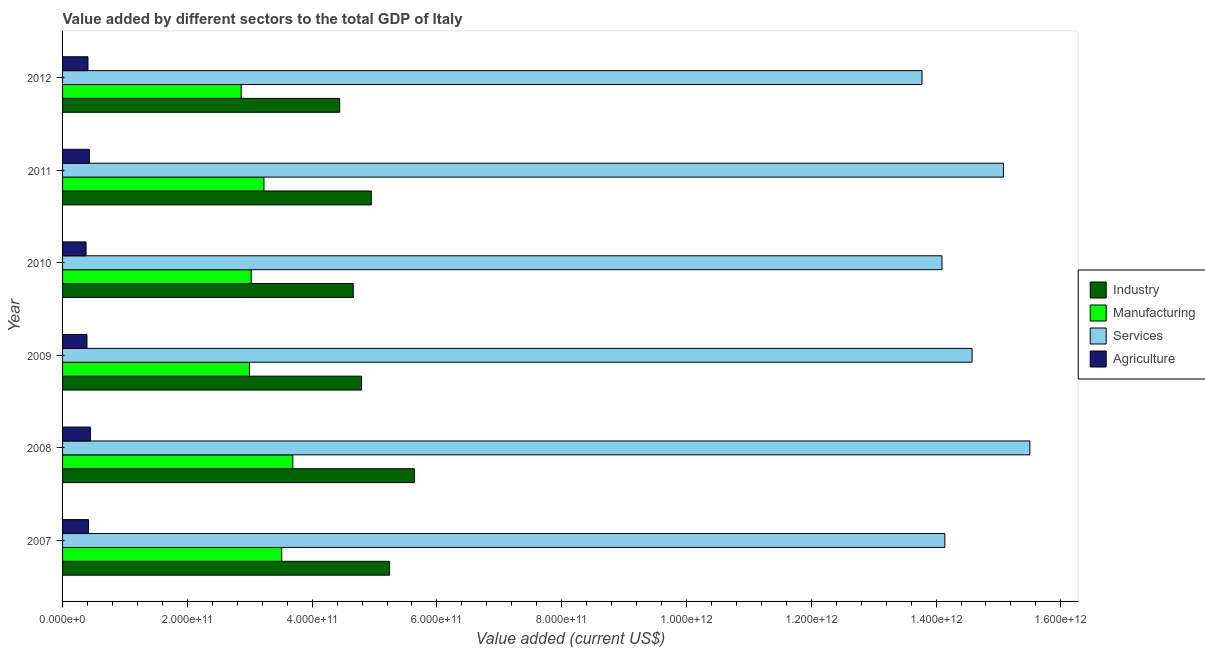How many groups of bars are there?
Provide a short and direct response. 6. What is the label of the 1st group of bars from the top?
Ensure brevity in your answer.  2012. In how many cases, is the number of bars for a given year not equal to the number of legend labels?
Offer a terse response. 0. What is the value added by agricultural sector in 2009?
Offer a terse response. 3.91e+1. Across all years, what is the maximum value added by industrial sector?
Your answer should be compact. 5.64e+11. Across all years, what is the minimum value added by services sector?
Make the answer very short. 1.38e+12. In which year was the value added by manufacturing sector minimum?
Your response must be concise. 2012. What is the total value added by industrial sector in the graph?
Make the answer very short. 2.97e+12. What is the difference between the value added by services sector in 2007 and that in 2008?
Your answer should be very brief. -1.36e+11. What is the difference between the value added by agricultural sector in 2007 and the value added by industrial sector in 2011?
Your answer should be compact. -4.53e+11. What is the average value added by services sector per year?
Your response must be concise. 1.45e+12. In the year 2008, what is the difference between the value added by industrial sector and value added by services sector?
Make the answer very short. -9.86e+11. What is the ratio of the value added by services sector in 2008 to that in 2011?
Your response must be concise. 1.03. What is the difference between the highest and the second highest value added by industrial sector?
Your answer should be compact. 3.97e+1. What is the difference between the highest and the lowest value added by agricultural sector?
Ensure brevity in your answer.  7.00e+09. Is the sum of the value added by industrial sector in 2007 and 2011 greater than the maximum value added by agricultural sector across all years?
Give a very brief answer. Yes. What does the 1st bar from the top in 2009 represents?
Provide a short and direct response. Agriculture. What does the 1st bar from the bottom in 2010 represents?
Provide a succinct answer. Industry. How many bars are there?
Offer a very short reply. 24. Are all the bars in the graph horizontal?
Your response must be concise. Yes. How many years are there in the graph?
Your answer should be compact. 6. What is the difference between two consecutive major ticks on the X-axis?
Offer a very short reply. 2.00e+11. Are the values on the major ticks of X-axis written in scientific E-notation?
Your answer should be compact. Yes. Does the graph contain any zero values?
Your response must be concise. No. How many legend labels are there?
Make the answer very short. 4. What is the title of the graph?
Offer a terse response. Value added by different sectors to the total GDP of Italy. Does "Regional development banks" appear as one of the legend labels in the graph?
Keep it short and to the point. No. What is the label or title of the X-axis?
Your answer should be very brief. Value added (current US$). What is the Value added (current US$) in Industry in 2007?
Your answer should be very brief. 5.24e+11. What is the Value added (current US$) in Manufacturing in 2007?
Your answer should be compact. 3.51e+11. What is the Value added (current US$) in Services in 2007?
Your answer should be very brief. 1.41e+12. What is the Value added (current US$) in Agriculture in 2007?
Provide a short and direct response. 4.17e+1. What is the Value added (current US$) in Industry in 2008?
Give a very brief answer. 5.64e+11. What is the Value added (current US$) in Manufacturing in 2008?
Give a very brief answer. 3.69e+11. What is the Value added (current US$) in Services in 2008?
Provide a succinct answer. 1.55e+12. What is the Value added (current US$) of Agriculture in 2008?
Your response must be concise. 4.46e+1. What is the Value added (current US$) in Industry in 2009?
Make the answer very short. 4.79e+11. What is the Value added (current US$) of Manufacturing in 2009?
Provide a succinct answer. 3.00e+11. What is the Value added (current US$) in Services in 2009?
Offer a terse response. 1.46e+12. What is the Value added (current US$) in Agriculture in 2009?
Your answer should be very brief. 3.91e+1. What is the Value added (current US$) in Industry in 2010?
Provide a short and direct response. 4.66e+11. What is the Value added (current US$) in Manufacturing in 2010?
Provide a succinct answer. 3.02e+11. What is the Value added (current US$) in Services in 2010?
Offer a very short reply. 1.41e+12. What is the Value added (current US$) in Agriculture in 2010?
Provide a succinct answer. 3.76e+1. What is the Value added (current US$) in Industry in 2011?
Your answer should be compact. 4.95e+11. What is the Value added (current US$) of Manufacturing in 2011?
Keep it short and to the point. 3.23e+11. What is the Value added (current US$) in Services in 2011?
Provide a short and direct response. 1.51e+12. What is the Value added (current US$) in Agriculture in 2011?
Give a very brief answer. 4.29e+1. What is the Value added (current US$) of Industry in 2012?
Provide a succinct answer. 4.44e+11. What is the Value added (current US$) in Manufacturing in 2012?
Give a very brief answer. 2.86e+11. What is the Value added (current US$) in Services in 2012?
Ensure brevity in your answer.  1.38e+12. What is the Value added (current US$) in Agriculture in 2012?
Offer a very short reply. 4.07e+1. Across all years, what is the maximum Value added (current US$) in Industry?
Ensure brevity in your answer.  5.64e+11. Across all years, what is the maximum Value added (current US$) of Manufacturing?
Give a very brief answer. 3.69e+11. Across all years, what is the maximum Value added (current US$) in Services?
Provide a short and direct response. 1.55e+12. Across all years, what is the maximum Value added (current US$) of Agriculture?
Keep it short and to the point. 4.46e+1. Across all years, what is the minimum Value added (current US$) of Industry?
Ensure brevity in your answer.  4.44e+11. Across all years, what is the minimum Value added (current US$) of Manufacturing?
Your answer should be very brief. 2.86e+11. Across all years, what is the minimum Value added (current US$) of Services?
Your answer should be compact. 1.38e+12. Across all years, what is the minimum Value added (current US$) of Agriculture?
Give a very brief answer. 3.76e+1. What is the total Value added (current US$) of Industry in the graph?
Offer a terse response. 2.97e+12. What is the total Value added (current US$) of Manufacturing in the graph?
Your answer should be compact. 1.93e+12. What is the total Value added (current US$) in Services in the graph?
Keep it short and to the point. 8.72e+12. What is the total Value added (current US$) of Agriculture in the graph?
Your answer should be compact. 2.47e+11. What is the difference between the Value added (current US$) of Industry in 2007 and that in 2008?
Provide a succinct answer. -3.97e+1. What is the difference between the Value added (current US$) of Manufacturing in 2007 and that in 2008?
Offer a terse response. -1.77e+1. What is the difference between the Value added (current US$) of Services in 2007 and that in 2008?
Provide a succinct answer. -1.36e+11. What is the difference between the Value added (current US$) in Agriculture in 2007 and that in 2008?
Offer a terse response. -2.98e+09. What is the difference between the Value added (current US$) in Industry in 2007 and that in 2009?
Your answer should be compact. 4.49e+1. What is the difference between the Value added (current US$) of Manufacturing in 2007 and that in 2009?
Offer a very short reply. 5.17e+1. What is the difference between the Value added (current US$) of Services in 2007 and that in 2009?
Give a very brief answer. -4.36e+1. What is the difference between the Value added (current US$) in Agriculture in 2007 and that in 2009?
Your answer should be very brief. 2.55e+09. What is the difference between the Value added (current US$) of Industry in 2007 and that in 2010?
Provide a short and direct response. 5.82e+1. What is the difference between the Value added (current US$) of Manufacturing in 2007 and that in 2010?
Offer a very short reply. 4.89e+1. What is the difference between the Value added (current US$) in Services in 2007 and that in 2010?
Your answer should be compact. 4.55e+09. What is the difference between the Value added (current US$) of Agriculture in 2007 and that in 2010?
Ensure brevity in your answer.  4.02e+09. What is the difference between the Value added (current US$) in Industry in 2007 and that in 2011?
Provide a succinct answer. 2.93e+1. What is the difference between the Value added (current US$) of Manufacturing in 2007 and that in 2011?
Give a very brief answer. 2.85e+1. What is the difference between the Value added (current US$) of Services in 2007 and that in 2011?
Provide a succinct answer. -9.39e+1. What is the difference between the Value added (current US$) of Agriculture in 2007 and that in 2011?
Provide a succinct answer. -1.27e+09. What is the difference between the Value added (current US$) in Industry in 2007 and that in 2012?
Offer a terse response. 8.00e+1. What is the difference between the Value added (current US$) of Manufacturing in 2007 and that in 2012?
Your answer should be very brief. 6.50e+1. What is the difference between the Value added (current US$) of Services in 2007 and that in 2012?
Your answer should be compact. 3.67e+1. What is the difference between the Value added (current US$) in Agriculture in 2007 and that in 2012?
Keep it short and to the point. 9.26e+08. What is the difference between the Value added (current US$) of Industry in 2008 and that in 2009?
Offer a terse response. 8.46e+1. What is the difference between the Value added (current US$) of Manufacturing in 2008 and that in 2009?
Make the answer very short. 6.95e+1. What is the difference between the Value added (current US$) of Services in 2008 and that in 2009?
Give a very brief answer. 9.26e+1. What is the difference between the Value added (current US$) in Agriculture in 2008 and that in 2009?
Offer a very short reply. 5.53e+09. What is the difference between the Value added (current US$) in Industry in 2008 and that in 2010?
Your answer should be very brief. 9.79e+1. What is the difference between the Value added (current US$) in Manufacturing in 2008 and that in 2010?
Your response must be concise. 6.66e+1. What is the difference between the Value added (current US$) of Services in 2008 and that in 2010?
Provide a succinct answer. 1.41e+11. What is the difference between the Value added (current US$) of Agriculture in 2008 and that in 2010?
Offer a terse response. 7.00e+09. What is the difference between the Value added (current US$) in Industry in 2008 and that in 2011?
Provide a succinct answer. 6.91e+1. What is the difference between the Value added (current US$) in Manufacturing in 2008 and that in 2011?
Your answer should be compact. 4.62e+1. What is the difference between the Value added (current US$) of Services in 2008 and that in 2011?
Provide a succinct answer. 4.23e+1. What is the difference between the Value added (current US$) in Agriculture in 2008 and that in 2011?
Ensure brevity in your answer.  1.71e+09. What is the difference between the Value added (current US$) of Industry in 2008 and that in 2012?
Your response must be concise. 1.20e+11. What is the difference between the Value added (current US$) in Manufacturing in 2008 and that in 2012?
Give a very brief answer. 8.27e+1. What is the difference between the Value added (current US$) in Services in 2008 and that in 2012?
Your answer should be very brief. 1.73e+11. What is the difference between the Value added (current US$) in Agriculture in 2008 and that in 2012?
Make the answer very short. 3.91e+09. What is the difference between the Value added (current US$) in Industry in 2009 and that in 2010?
Provide a short and direct response. 1.33e+1. What is the difference between the Value added (current US$) in Manufacturing in 2009 and that in 2010?
Give a very brief answer. -2.81e+09. What is the difference between the Value added (current US$) of Services in 2009 and that in 2010?
Your answer should be very brief. 4.82e+1. What is the difference between the Value added (current US$) in Agriculture in 2009 and that in 2010?
Make the answer very short. 1.47e+09. What is the difference between the Value added (current US$) of Industry in 2009 and that in 2011?
Give a very brief answer. -1.55e+1. What is the difference between the Value added (current US$) of Manufacturing in 2009 and that in 2011?
Ensure brevity in your answer.  -2.32e+1. What is the difference between the Value added (current US$) of Services in 2009 and that in 2011?
Offer a terse response. -5.03e+1. What is the difference between the Value added (current US$) of Agriculture in 2009 and that in 2011?
Give a very brief answer. -3.82e+09. What is the difference between the Value added (current US$) in Industry in 2009 and that in 2012?
Provide a succinct answer. 3.51e+1. What is the difference between the Value added (current US$) in Manufacturing in 2009 and that in 2012?
Provide a short and direct response. 1.33e+1. What is the difference between the Value added (current US$) of Services in 2009 and that in 2012?
Provide a succinct answer. 8.03e+1. What is the difference between the Value added (current US$) in Agriculture in 2009 and that in 2012?
Keep it short and to the point. -1.62e+09. What is the difference between the Value added (current US$) of Industry in 2010 and that in 2011?
Offer a very short reply. -2.89e+1. What is the difference between the Value added (current US$) in Manufacturing in 2010 and that in 2011?
Offer a very short reply. -2.04e+1. What is the difference between the Value added (current US$) of Services in 2010 and that in 2011?
Offer a terse response. -9.85e+1. What is the difference between the Value added (current US$) of Agriculture in 2010 and that in 2011?
Keep it short and to the point. -5.29e+09. What is the difference between the Value added (current US$) of Industry in 2010 and that in 2012?
Ensure brevity in your answer.  2.18e+1. What is the difference between the Value added (current US$) in Manufacturing in 2010 and that in 2012?
Offer a terse response. 1.61e+1. What is the difference between the Value added (current US$) in Services in 2010 and that in 2012?
Provide a succinct answer. 3.21e+1. What is the difference between the Value added (current US$) in Agriculture in 2010 and that in 2012?
Give a very brief answer. -3.09e+09. What is the difference between the Value added (current US$) of Industry in 2011 and that in 2012?
Offer a very short reply. 5.07e+1. What is the difference between the Value added (current US$) of Manufacturing in 2011 and that in 2012?
Offer a terse response. 3.65e+1. What is the difference between the Value added (current US$) in Services in 2011 and that in 2012?
Keep it short and to the point. 1.31e+11. What is the difference between the Value added (current US$) of Agriculture in 2011 and that in 2012?
Make the answer very short. 2.20e+09. What is the difference between the Value added (current US$) of Industry in 2007 and the Value added (current US$) of Manufacturing in 2008?
Give a very brief answer. 1.55e+11. What is the difference between the Value added (current US$) in Industry in 2007 and the Value added (current US$) in Services in 2008?
Offer a very short reply. -1.03e+12. What is the difference between the Value added (current US$) of Industry in 2007 and the Value added (current US$) of Agriculture in 2008?
Your response must be concise. 4.80e+11. What is the difference between the Value added (current US$) in Manufacturing in 2007 and the Value added (current US$) in Services in 2008?
Provide a succinct answer. -1.20e+12. What is the difference between the Value added (current US$) of Manufacturing in 2007 and the Value added (current US$) of Agriculture in 2008?
Ensure brevity in your answer.  3.07e+11. What is the difference between the Value added (current US$) of Services in 2007 and the Value added (current US$) of Agriculture in 2008?
Keep it short and to the point. 1.37e+12. What is the difference between the Value added (current US$) in Industry in 2007 and the Value added (current US$) in Manufacturing in 2009?
Offer a very short reply. 2.25e+11. What is the difference between the Value added (current US$) in Industry in 2007 and the Value added (current US$) in Services in 2009?
Your answer should be very brief. -9.34e+11. What is the difference between the Value added (current US$) of Industry in 2007 and the Value added (current US$) of Agriculture in 2009?
Provide a succinct answer. 4.85e+11. What is the difference between the Value added (current US$) of Manufacturing in 2007 and the Value added (current US$) of Services in 2009?
Give a very brief answer. -1.11e+12. What is the difference between the Value added (current US$) in Manufacturing in 2007 and the Value added (current US$) in Agriculture in 2009?
Provide a short and direct response. 3.12e+11. What is the difference between the Value added (current US$) in Services in 2007 and the Value added (current US$) in Agriculture in 2009?
Your response must be concise. 1.38e+12. What is the difference between the Value added (current US$) in Industry in 2007 and the Value added (current US$) in Manufacturing in 2010?
Offer a terse response. 2.22e+11. What is the difference between the Value added (current US$) in Industry in 2007 and the Value added (current US$) in Services in 2010?
Make the answer very short. -8.85e+11. What is the difference between the Value added (current US$) in Industry in 2007 and the Value added (current US$) in Agriculture in 2010?
Keep it short and to the point. 4.87e+11. What is the difference between the Value added (current US$) of Manufacturing in 2007 and the Value added (current US$) of Services in 2010?
Your answer should be very brief. -1.06e+12. What is the difference between the Value added (current US$) in Manufacturing in 2007 and the Value added (current US$) in Agriculture in 2010?
Your response must be concise. 3.14e+11. What is the difference between the Value added (current US$) of Services in 2007 and the Value added (current US$) of Agriculture in 2010?
Give a very brief answer. 1.38e+12. What is the difference between the Value added (current US$) in Industry in 2007 and the Value added (current US$) in Manufacturing in 2011?
Your response must be concise. 2.01e+11. What is the difference between the Value added (current US$) of Industry in 2007 and the Value added (current US$) of Services in 2011?
Provide a short and direct response. -9.84e+11. What is the difference between the Value added (current US$) in Industry in 2007 and the Value added (current US$) in Agriculture in 2011?
Offer a very short reply. 4.81e+11. What is the difference between the Value added (current US$) in Manufacturing in 2007 and the Value added (current US$) in Services in 2011?
Provide a short and direct response. -1.16e+12. What is the difference between the Value added (current US$) of Manufacturing in 2007 and the Value added (current US$) of Agriculture in 2011?
Your answer should be compact. 3.08e+11. What is the difference between the Value added (current US$) of Services in 2007 and the Value added (current US$) of Agriculture in 2011?
Offer a very short reply. 1.37e+12. What is the difference between the Value added (current US$) in Industry in 2007 and the Value added (current US$) in Manufacturing in 2012?
Offer a terse response. 2.38e+11. What is the difference between the Value added (current US$) of Industry in 2007 and the Value added (current US$) of Services in 2012?
Ensure brevity in your answer.  -8.53e+11. What is the difference between the Value added (current US$) in Industry in 2007 and the Value added (current US$) in Agriculture in 2012?
Your response must be concise. 4.83e+11. What is the difference between the Value added (current US$) in Manufacturing in 2007 and the Value added (current US$) in Services in 2012?
Keep it short and to the point. -1.03e+12. What is the difference between the Value added (current US$) in Manufacturing in 2007 and the Value added (current US$) in Agriculture in 2012?
Ensure brevity in your answer.  3.11e+11. What is the difference between the Value added (current US$) of Services in 2007 and the Value added (current US$) of Agriculture in 2012?
Your answer should be very brief. 1.37e+12. What is the difference between the Value added (current US$) in Industry in 2008 and the Value added (current US$) in Manufacturing in 2009?
Your answer should be very brief. 2.64e+11. What is the difference between the Value added (current US$) of Industry in 2008 and the Value added (current US$) of Services in 2009?
Make the answer very short. -8.94e+11. What is the difference between the Value added (current US$) of Industry in 2008 and the Value added (current US$) of Agriculture in 2009?
Offer a terse response. 5.25e+11. What is the difference between the Value added (current US$) in Manufacturing in 2008 and the Value added (current US$) in Services in 2009?
Make the answer very short. -1.09e+12. What is the difference between the Value added (current US$) in Manufacturing in 2008 and the Value added (current US$) in Agriculture in 2009?
Offer a very short reply. 3.30e+11. What is the difference between the Value added (current US$) in Services in 2008 and the Value added (current US$) in Agriculture in 2009?
Give a very brief answer. 1.51e+12. What is the difference between the Value added (current US$) in Industry in 2008 and the Value added (current US$) in Manufacturing in 2010?
Provide a succinct answer. 2.61e+11. What is the difference between the Value added (current US$) in Industry in 2008 and the Value added (current US$) in Services in 2010?
Keep it short and to the point. -8.46e+11. What is the difference between the Value added (current US$) in Industry in 2008 and the Value added (current US$) in Agriculture in 2010?
Offer a very short reply. 5.26e+11. What is the difference between the Value added (current US$) in Manufacturing in 2008 and the Value added (current US$) in Services in 2010?
Provide a short and direct response. -1.04e+12. What is the difference between the Value added (current US$) in Manufacturing in 2008 and the Value added (current US$) in Agriculture in 2010?
Your answer should be very brief. 3.31e+11. What is the difference between the Value added (current US$) of Services in 2008 and the Value added (current US$) of Agriculture in 2010?
Offer a terse response. 1.51e+12. What is the difference between the Value added (current US$) of Industry in 2008 and the Value added (current US$) of Manufacturing in 2011?
Offer a very short reply. 2.41e+11. What is the difference between the Value added (current US$) in Industry in 2008 and the Value added (current US$) in Services in 2011?
Offer a very short reply. -9.44e+11. What is the difference between the Value added (current US$) in Industry in 2008 and the Value added (current US$) in Agriculture in 2011?
Keep it short and to the point. 5.21e+11. What is the difference between the Value added (current US$) in Manufacturing in 2008 and the Value added (current US$) in Services in 2011?
Keep it short and to the point. -1.14e+12. What is the difference between the Value added (current US$) in Manufacturing in 2008 and the Value added (current US$) in Agriculture in 2011?
Provide a succinct answer. 3.26e+11. What is the difference between the Value added (current US$) in Services in 2008 and the Value added (current US$) in Agriculture in 2011?
Provide a short and direct response. 1.51e+12. What is the difference between the Value added (current US$) of Industry in 2008 and the Value added (current US$) of Manufacturing in 2012?
Give a very brief answer. 2.78e+11. What is the difference between the Value added (current US$) of Industry in 2008 and the Value added (current US$) of Services in 2012?
Ensure brevity in your answer.  -8.14e+11. What is the difference between the Value added (current US$) in Industry in 2008 and the Value added (current US$) in Agriculture in 2012?
Your response must be concise. 5.23e+11. What is the difference between the Value added (current US$) of Manufacturing in 2008 and the Value added (current US$) of Services in 2012?
Offer a terse response. -1.01e+12. What is the difference between the Value added (current US$) in Manufacturing in 2008 and the Value added (current US$) in Agriculture in 2012?
Your response must be concise. 3.28e+11. What is the difference between the Value added (current US$) of Services in 2008 and the Value added (current US$) of Agriculture in 2012?
Your response must be concise. 1.51e+12. What is the difference between the Value added (current US$) in Industry in 2009 and the Value added (current US$) in Manufacturing in 2010?
Offer a terse response. 1.77e+11. What is the difference between the Value added (current US$) in Industry in 2009 and the Value added (current US$) in Services in 2010?
Your answer should be very brief. -9.30e+11. What is the difference between the Value added (current US$) of Industry in 2009 and the Value added (current US$) of Agriculture in 2010?
Your answer should be compact. 4.42e+11. What is the difference between the Value added (current US$) of Manufacturing in 2009 and the Value added (current US$) of Services in 2010?
Your answer should be compact. -1.11e+12. What is the difference between the Value added (current US$) of Manufacturing in 2009 and the Value added (current US$) of Agriculture in 2010?
Provide a succinct answer. 2.62e+11. What is the difference between the Value added (current US$) of Services in 2009 and the Value added (current US$) of Agriculture in 2010?
Ensure brevity in your answer.  1.42e+12. What is the difference between the Value added (current US$) of Industry in 2009 and the Value added (current US$) of Manufacturing in 2011?
Provide a succinct answer. 1.57e+11. What is the difference between the Value added (current US$) in Industry in 2009 and the Value added (current US$) in Services in 2011?
Your answer should be compact. -1.03e+12. What is the difference between the Value added (current US$) in Industry in 2009 and the Value added (current US$) in Agriculture in 2011?
Offer a terse response. 4.36e+11. What is the difference between the Value added (current US$) in Manufacturing in 2009 and the Value added (current US$) in Services in 2011?
Offer a very short reply. -1.21e+12. What is the difference between the Value added (current US$) of Manufacturing in 2009 and the Value added (current US$) of Agriculture in 2011?
Your response must be concise. 2.57e+11. What is the difference between the Value added (current US$) of Services in 2009 and the Value added (current US$) of Agriculture in 2011?
Offer a terse response. 1.41e+12. What is the difference between the Value added (current US$) in Industry in 2009 and the Value added (current US$) in Manufacturing in 2012?
Your answer should be very brief. 1.93e+11. What is the difference between the Value added (current US$) in Industry in 2009 and the Value added (current US$) in Services in 2012?
Give a very brief answer. -8.98e+11. What is the difference between the Value added (current US$) in Industry in 2009 and the Value added (current US$) in Agriculture in 2012?
Offer a terse response. 4.39e+11. What is the difference between the Value added (current US$) in Manufacturing in 2009 and the Value added (current US$) in Services in 2012?
Offer a terse response. -1.08e+12. What is the difference between the Value added (current US$) in Manufacturing in 2009 and the Value added (current US$) in Agriculture in 2012?
Keep it short and to the point. 2.59e+11. What is the difference between the Value added (current US$) of Services in 2009 and the Value added (current US$) of Agriculture in 2012?
Provide a succinct answer. 1.42e+12. What is the difference between the Value added (current US$) in Industry in 2010 and the Value added (current US$) in Manufacturing in 2011?
Offer a terse response. 1.43e+11. What is the difference between the Value added (current US$) in Industry in 2010 and the Value added (current US$) in Services in 2011?
Your answer should be compact. -1.04e+12. What is the difference between the Value added (current US$) in Industry in 2010 and the Value added (current US$) in Agriculture in 2011?
Offer a very short reply. 4.23e+11. What is the difference between the Value added (current US$) in Manufacturing in 2010 and the Value added (current US$) in Services in 2011?
Your response must be concise. -1.21e+12. What is the difference between the Value added (current US$) of Manufacturing in 2010 and the Value added (current US$) of Agriculture in 2011?
Your response must be concise. 2.59e+11. What is the difference between the Value added (current US$) in Services in 2010 and the Value added (current US$) in Agriculture in 2011?
Your response must be concise. 1.37e+12. What is the difference between the Value added (current US$) of Industry in 2010 and the Value added (current US$) of Manufacturing in 2012?
Give a very brief answer. 1.80e+11. What is the difference between the Value added (current US$) in Industry in 2010 and the Value added (current US$) in Services in 2012?
Offer a terse response. -9.12e+11. What is the difference between the Value added (current US$) of Industry in 2010 and the Value added (current US$) of Agriculture in 2012?
Ensure brevity in your answer.  4.25e+11. What is the difference between the Value added (current US$) in Manufacturing in 2010 and the Value added (current US$) in Services in 2012?
Your answer should be very brief. -1.08e+12. What is the difference between the Value added (current US$) in Manufacturing in 2010 and the Value added (current US$) in Agriculture in 2012?
Your answer should be very brief. 2.62e+11. What is the difference between the Value added (current US$) of Services in 2010 and the Value added (current US$) of Agriculture in 2012?
Keep it short and to the point. 1.37e+12. What is the difference between the Value added (current US$) of Industry in 2011 and the Value added (current US$) of Manufacturing in 2012?
Your answer should be very brief. 2.09e+11. What is the difference between the Value added (current US$) in Industry in 2011 and the Value added (current US$) in Services in 2012?
Make the answer very short. -8.83e+11. What is the difference between the Value added (current US$) in Industry in 2011 and the Value added (current US$) in Agriculture in 2012?
Give a very brief answer. 4.54e+11. What is the difference between the Value added (current US$) in Manufacturing in 2011 and the Value added (current US$) in Services in 2012?
Make the answer very short. -1.05e+12. What is the difference between the Value added (current US$) of Manufacturing in 2011 and the Value added (current US$) of Agriculture in 2012?
Provide a succinct answer. 2.82e+11. What is the difference between the Value added (current US$) in Services in 2011 and the Value added (current US$) in Agriculture in 2012?
Offer a very short reply. 1.47e+12. What is the average Value added (current US$) in Industry per year?
Keep it short and to the point. 4.95e+11. What is the average Value added (current US$) in Manufacturing per year?
Make the answer very short. 3.22e+11. What is the average Value added (current US$) in Services per year?
Make the answer very short. 1.45e+12. What is the average Value added (current US$) of Agriculture per year?
Your answer should be very brief. 4.11e+1. In the year 2007, what is the difference between the Value added (current US$) of Industry and Value added (current US$) of Manufacturing?
Your response must be concise. 1.73e+11. In the year 2007, what is the difference between the Value added (current US$) of Industry and Value added (current US$) of Services?
Your answer should be compact. -8.90e+11. In the year 2007, what is the difference between the Value added (current US$) of Industry and Value added (current US$) of Agriculture?
Your response must be concise. 4.82e+11. In the year 2007, what is the difference between the Value added (current US$) of Manufacturing and Value added (current US$) of Services?
Your answer should be compact. -1.06e+12. In the year 2007, what is the difference between the Value added (current US$) in Manufacturing and Value added (current US$) in Agriculture?
Make the answer very short. 3.10e+11. In the year 2007, what is the difference between the Value added (current US$) in Services and Value added (current US$) in Agriculture?
Provide a short and direct response. 1.37e+12. In the year 2008, what is the difference between the Value added (current US$) in Industry and Value added (current US$) in Manufacturing?
Make the answer very short. 1.95e+11. In the year 2008, what is the difference between the Value added (current US$) of Industry and Value added (current US$) of Services?
Offer a terse response. -9.86e+11. In the year 2008, what is the difference between the Value added (current US$) of Industry and Value added (current US$) of Agriculture?
Offer a very short reply. 5.19e+11. In the year 2008, what is the difference between the Value added (current US$) in Manufacturing and Value added (current US$) in Services?
Offer a terse response. -1.18e+12. In the year 2008, what is the difference between the Value added (current US$) of Manufacturing and Value added (current US$) of Agriculture?
Give a very brief answer. 3.24e+11. In the year 2008, what is the difference between the Value added (current US$) of Services and Value added (current US$) of Agriculture?
Ensure brevity in your answer.  1.51e+12. In the year 2009, what is the difference between the Value added (current US$) of Industry and Value added (current US$) of Manufacturing?
Give a very brief answer. 1.80e+11. In the year 2009, what is the difference between the Value added (current US$) of Industry and Value added (current US$) of Services?
Offer a very short reply. -9.78e+11. In the year 2009, what is the difference between the Value added (current US$) in Industry and Value added (current US$) in Agriculture?
Provide a short and direct response. 4.40e+11. In the year 2009, what is the difference between the Value added (current US$) in Manufacturing and Value added (current US$) in Services?
Give a very brief answer. -1.16e+12. In the year 2009, what is the difference between the Value added (current US$) of Manufacturing and Value added (current US$) of Agriculture?
Make the answer very short. 2.60e+11. In the year 2009, what is the difference between the Value added (current US$) in Services and Value added (current US$) in Agriculture?
Make the answer very short. 1.42e+12. In the year 2010, what is the difference between the Value added (current US$) in Industry and Value added (current US$) in Manufacturing?
Give a very brief answer. 1.64e+11. In the year 2010, what is the difference between the Value added (current US$) of Industry and Value added (current US$) of Services?
Provide a short and direct response. -9.44e+11. In the year 2010, what is the difference between the Value added (current US$) of Industry and Value added (current US$) of Agriculture?
Keep it short and to the point. 4.28e+11. In the year 2010, what is the difference between the Value added (current US$) in Manufacturing and Value added (current US$) in Services?
Your response must be concise. -1.11e+12. In the year 2010, what is the difference between the Value added (current US$) in Manufacturing and Value added (current US$) in Agriculture?
Your answer should be very brief. 2.65e+11. In the year 2010, what is the difference between the Value added (current US$) in Services and Value added (current US$) in Agriculture?
Ensure brevity in your answer.  1.37e+12. In the year 2011, what is the difference between the Value added (current US$) in Industry and Value added (current US$) in Manufacturing?
Your answer should be compact. 1.72e+11. In the year 2011, what is the difference between the Value added (current US$) of Industry and Value added (current US$) of Services?
Your answer should be very brief. -1.01e+12. In the year 2011, what is the difference between the Value added (current US$) in Industry and Value added (current US$) in Agriculture?
Your response must be concise. 4.52e+11. In the year 2011, what is the difference between the Value added (current US$) in Manufacturing and Value added (current US$) in Services?
Provide a succinct answer. -1.19e+12. In the year 2011, what is the difference between the Value added (current US$) of Manufacturing and Value added (current US$) of Agriculture?
Your response must be concise. 2.80e+11. In the year 2011, what is the difference between the Value added (current US$) in Services and Value added (current US$) in Agriculture?
Keep it short and to the point. 1.47e+12. In the year 2012, what is the difference between the Value added (current US$) of Industry and Value added (current US$) of Manufacturing?
Keep it short and to the point. 1.58e+11. In the year 2012, what is the difference between the Value added (current US$) of Industry and Value added (current US$) of Services?
Your response must be concise. -9.33e+11. In the year 2012, what is the difference between the Value added (current US$) in Industry and Value added (current US$) in Agriculture?
Keep it short and to the point. 4.03e+11. In the year 2012, what is the difference between the Value added (current US$) of Manufacturing and Value added (current US$) of Services?
Your answer should be very brief. -1.09e+12. In the year 2012, what is the difference between the Value added (current US$) of Manufacturing and Value added (current US$) of Agriculture?
Keep it short and to the point. 2.46e+11. In the year 2012, what is the difference between the Value added (current US$) of Services and Value added (current US$) of Agriculture?
Provide a succinct answer. 1.34e+12. What is the ratio of the Value added (current US$) of Industry in 2007 to that in 2008?
Provide a short and direct response. 0.93. What is the ratio of the Value added (current US$) of Services in 2007 to that in 2008?
Ensure brevity in your answer.  0.91. What is the ratio of the Value added (current US$) in Agriculture in 2007 to that in 2008?
Your response must be concise. 0.93. What is the ratio of the Value added (current US$) in Industry in 2007 to that in 2009?
Make the answer very short. 1.09. What is the ratio of the Value added (current US$) of Manufacturing in 2007 to that in 2009?
Your answer should be very brief. 1.17. What is the ratio of the Value added (current US$) of Services in 2007 to that in 2009?
Your response must be concise. 0.97. What is the ratio of the Value added (current US$) of Agriculture in 2007 to that in 2009?
Your answer should be compact. 1.07. What is the ratio of the Value added (current US$) in Industry in 2007 to that in 2010?
Offer a very short reply. 1.12. What is the ratio of the Value added (current US$) of Manufacturing in 2007 to that in 2010?
Provide a short and direct response. 1.16. What is the ratio of the Value added (current US$) in Services in 2007 to that in 2010?
Provide a short and direct response. 1. What is the ratio of the Value added (current US$) in Agriculture in 2007 to that in 2010?
Your answer should be compact. 1.11. What is the ratio of the Value added (current US$) in Industry in 2007 to that in 2011?
Make the answer very short. 1.06. What is the ratio of the Value added (current US$) in Manufacturing in 2007 to that in 2011?
Provide a short and direct response. 1.09. What is the ratio of the Value added (current US$) in Services in 2007 to that in 2011?
Give a very brief answer. 0.94. What is the ratio of the Value added (current US$) in Agriculture in 2007 to that in 2011?
Make the answer very short. 0.97. What is the ratio of the Value added (current US$) of Industry in 2007 to that in 2012?
Offer a terse response. 1.18. What is the ratio of the Value added (current US$) of Manufacturing in 2007 to that in 2012?
Ensure brevity in your answer.  1.23. What is the ratio of the Value added (current US$) of Services in 2007 to that in 2012?
Keep it short and to the point. 1.03. What is the ratio of the Value added (current US$) of Agriculture in 2007 to that in 2012?
Offer a very short reply. 1.02. What is the ratio of the Value added (current US$) of Industry in 2008 to that in 2009?
Offer a terse response. 1.18. What is the ratio of the Value added (current US$) of Manufacturing in 2008 to that in 2009?
Give a very brief answer. 1.23. What is the ratio of the Value added (current US$) of Services in 2008 to that in 2009?
Make the answer very short. 1.06. What is the ratio of the Value added (current US$) of Agriculture in 2008 to that in 2009?
Give a very brief answer. 1.14. What is the ratio of the Value added (current US$) in Industry in 2008 to that in 2010?
Your answer should be compact. 1.21. What is the ratio of the Value added (current US$) in Manufacturing in 2008 to that in 2010?
Give a very brief answer. 1.22. What is the ratio of the Value added (current US$) of Services in 2008 to that in 2010?
Provide a succinct answer. 1.1. What is the ratio of the Value added (current US$) in Agriculture in 2008 to that in 2010?
Give a very brief answer. 1.19. What is the ratio of the Value added (current US$) in Industry in 2008 to that in 2011?
Provide a succinct answer. 1.14. What is the ratio of the Value added (current US$) of Manufacturing in 2008 to that in 2011?
Offer a terse response. 1.14. What is the ratio of the Value added (current US$) of Services in 2008 to that in 2011?
Make the answer very short. 1.03. What is the ratio of the Value added (current US$) in Agriculture in 2008 to that in 2011?
Ensure brevity in your answer.  1.04. What is the ratio of the Value added (current US$) in Industry in 2008 to that in 2012?
Your answer should be very brief. 1.27. What is the ratio of the Value added (current US$) in Manufacturing in 2008 to that in 2012?
Offer a terse response. 1.29. What is the ratio of the Value added (current US$) in Services in 2008 to that in 2012?
Ensure brevity in your answer.  1.13. What is the ratio of the Value added (current US$) of Agriculture in 2008 to that in 2012?
Offer a terse response. 1.1. What is the ratio of the Value added (current US$) of Industry in 2009 to that in 2010?
Your answer should be very brief. 1.03. What is the ratio of the Value added (current US$) in Manufacturing in 2009 to that in 2010?
Your response must be concise. 0.99. What is the ratio of the Value added (current US$) in Services in 2009 to that in 2010?
Provide a succinct answer. 1.03. What is the ratio of the Value added (current US$) in Agriculture in 2009 to that in 2010?
Your response must be concise. 1.04. What is the ratio of the Value added (current US$) in Industry in 2009 to that in 2011?
Provide a short and direct response. 0.97. What is the ratio of the Value added (current US$) of Manufacturing in 2009 to that in 2011?
Provide a succinct answer. 0.93. What is the ratio of the Value added (current US$) in Services in 2009 to that in 2011?
Give a very brief answer. 0.97. What is the ratio of the Value added (current US$) in Agriculture in 2009 to that in 2011?
Offer a terse response. 0.91. What is the ratio of the Value added (current US$) in Industry in 2009 to that in 2012?
Your answer should be very brief. 1.08. What is the ratio of the Value added (current US$) in Manufacturing in 2009 to that in 2012?
Your response must be concise. 1.05. What is the ratio of the Value added (current US$) of Services in 2009 to that in 2012?
Your response must be concise. 1.06. What is the ratio of the Value added (current US$) in Agriculture in 2009 to that in 2012?
Offer a terse response. 0.96. What is the ratio of the Value added (current US$) in Industry in 2010 to that in 2011?
Your answer should be very brief. 0.94. What is the ratio of the Value added (current US$) of Manufacturing in 2010 to that in 2011?
Provide a short and direct response. 0.94. What is the ratio of the Value added (current US$) of Services in 2010 to that in 2011?
Your answer should be very brief. 0.93. What is the ratio of the Value added (current US$) of Agriculture in 2010 to that in 2011?
Offer a very short reply. 0.88. What is the ratio of the Value added (current US$) of Industry in 2010 to that in 2012?
Your response must be concise. 1.05. What is the ratio of the Value added (current US$) in Manufacturing in 2010 to that in 2012?
Your response must be concise. 1.06. What is the ratio of the Value added (current US$) of Services in 2010 to that in 2012?
Offer a terse response. 1.02. What is the ratio of the Value added (current US$) in Agriculture in 2010 to that in 2012?
Provide a succinct answer. 0.92. What is the ratio of the Value added (current US$) of Industry in 2011 to that in 2012?
Your answer should be compact. 1.11. What is the ratio of the Value added (current US$) of Manufacturing in 2011 to that in 2012?
Make the answer very short. 1.13. What is the ratio of the Value added (current US$) in Services in 2011 to that in 2012?
Your answer should be compact. 1.09. What is the ratio of the Value added (current US$) in Agriculture in 2011 to that in 2012?
Keep it short and to the point. 1.05. What is the difference between the highest and the second highest Value added (current US$) of Industry?
Your answer should be compact. 3.97e+1. What is the difference between the highest and the second highest Value added (current US$) of Manufacturing?
Your response must be concise. 1.77e+1. What is the difference between the highest and the second highest Value added (current US$) in Services?
Offer a terse response. 4.23e+1. What is the difference between the highest and the second highest Value added (current US$) of Agriculture?
Your answer should be compact. 1.71e+09. What is the difference between the highest and the lowest Value added (current US$) of Industry?
Give a very brief answer. 1.20e+11. What is the difference between the highest and the lowest Value added (current US$) in Manufacturing?
Your answer should be compact. 8.27e+1. What is the difference between the highest and the lowest Value added (current US$) in Services?
Offer a terse response. 1.73e+11. What is the difference between the highest and the lowest Value added (current US$) of Agriculture?
Make the answer very short. 7.00e+09. 